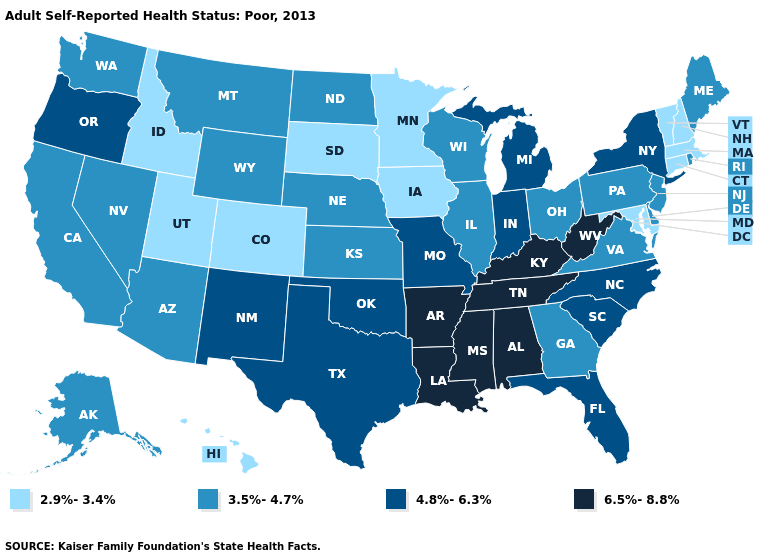Does West Virginia have a lower value than South Dakota?
Short answer required. No. Which states hav the highest value in the South?
Answer briefly. Alabama, Arkansas, Kentucky, Louisiana, Mississippi, Tennessee, West Virginia. What is the highest value in states that border Arkansas?
Quick response, please. 6.5%-8.8%. Does Colorado have the highest value in the USA?
Answer briefly. No. Name the states that have a value in the range 2.9%-3.4%?
Concise answer only. Colorado, Connecticut, Hawaii, Idaho, Iowa, Maryland, Massachusetts, Minnesota, New Hampshire, South Dakota, Utah, Vermont. Among the states that border Alabama , does Georgia have the lowest value?
Short answer required. Yes. What is the value of Oregon?
Be succinct. 4.8%-6.3%. Name the states that have a value in the range 2.9%-3.4%?
Give a very brief answer. Colorado, Connecticut, Hawaii, Idaho, Iowa, Maryland, Massachusetts, Minnesota, New Hampshire, South Dakota, Utah, Vermont. Which states have the lowest value in the USA?
Answer briefly. Colorado, Connecticut, Hawaii, Idaho, Iowa, Maryland, Massachusetts, Minnesota, New Hampshire, South Dakota, Utah, Vermont. Is the legend a continuous bar?
Answer briefly. No. What is the value of Tennessee?
Keep it brief. 6.5%-8.8%. Which states hav the highest value in the South?
Answer briefly. Alabama, Arkansas, Kentucky, Louisiana, Mississippi, Tennessee, West Virginia. How many symbols are there in the legend?
Quick response, please. 4. What is the value of Maryland?
Concise answer only. 2.9%-3.4%. What is the value of Oregon?
Write a very short answer. 4.8%-6.3%. 